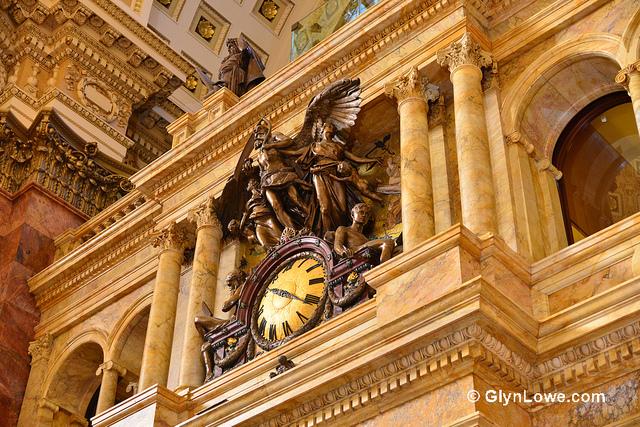What is the time on the clock?
Be succinct. 10:20. Where was the picture taken of the clock?
Write a very short answer. Church. Is this a palace?
Short answer required. Yes. How many arches are in the building?
Short answer required. 3. Is there anywhere to sit?
Be succinct. No. 